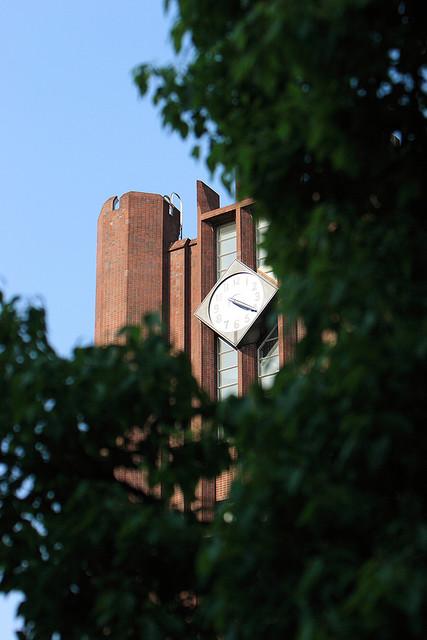Where is the clock?
Keep it brief. Building. What color is the building?
Answer briefly. Brown. What time does this clock have?
Short answer required. 4:20. What is in front of the clock?
Keep it brief. Tree. How many hours past tea-time does this clock read?
Answer briefly. 2. What kind of building is the clock on?
Give a very brief answer. Tower. Is this the bear's natural environment?
Answer briefly. No. 